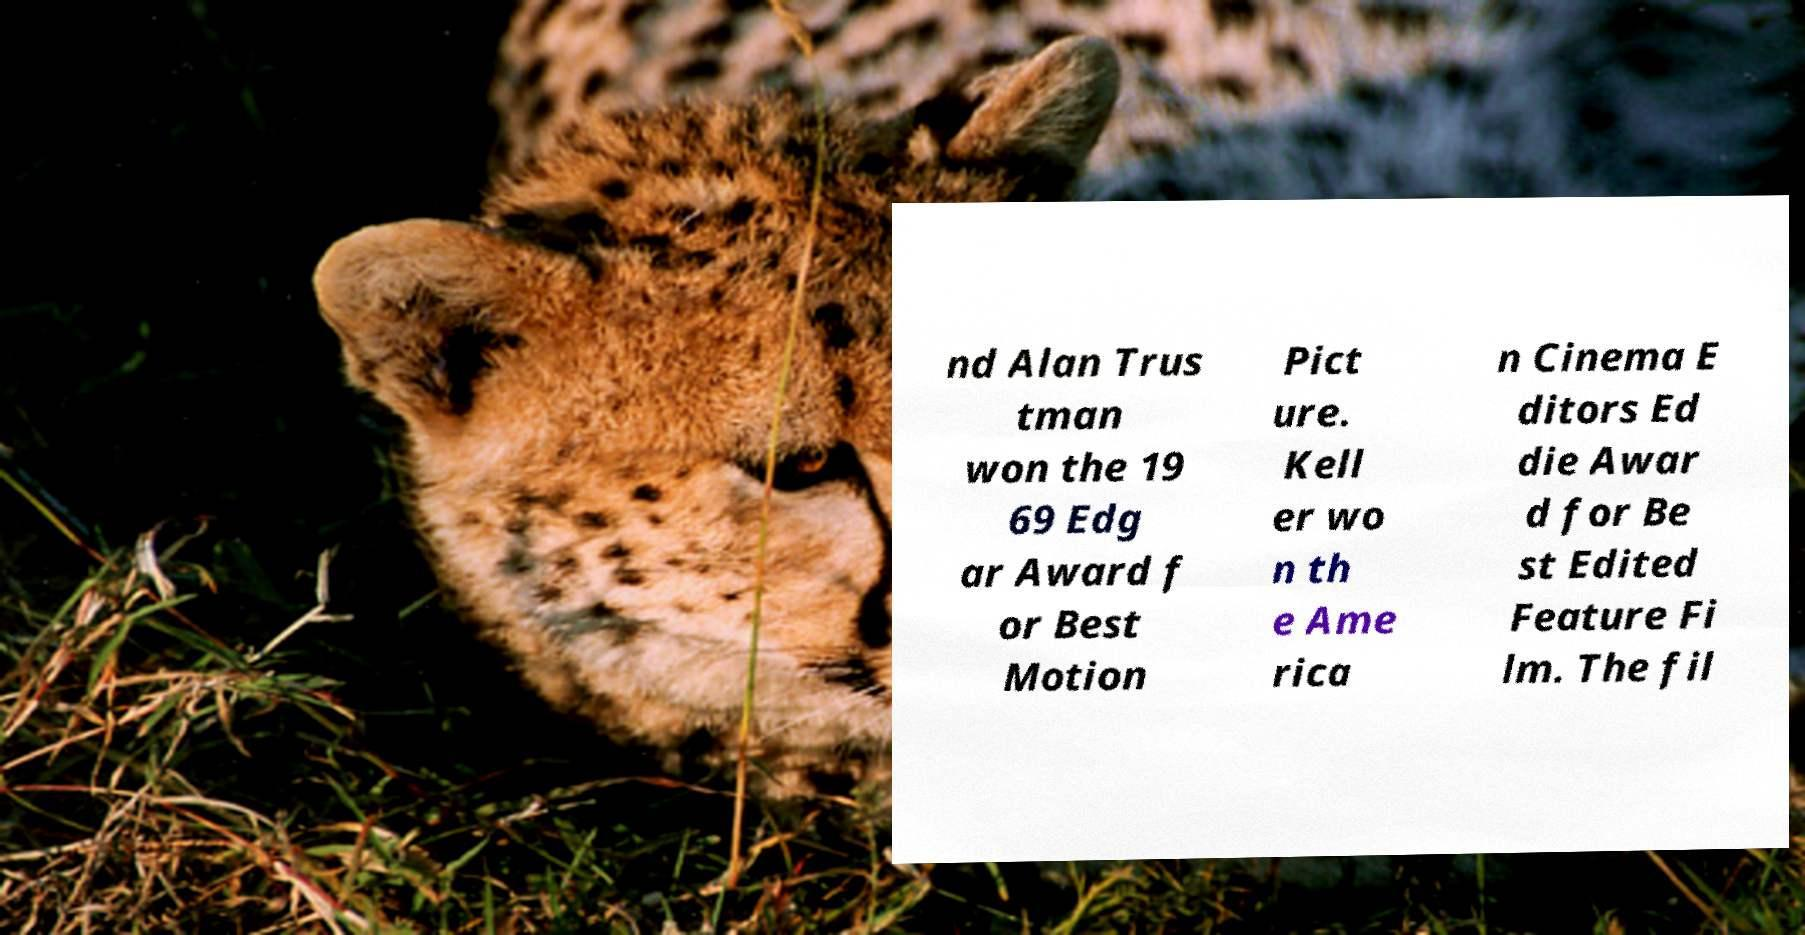Can you read and provide the text displayed in the image?This photo seems to have some interesting text. Can you extract and type it out for me? nd Alan Trus tman won the 19 69 Edg ar Award f or Best Motion Pict ure. Kell er wo n th e Ame rica n Cinema E ditors Ed die Awar d for Be st Edited Feature Fi lm. The fil 